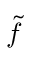<formula> <loc_0><loc_0><loc_500><loc_500>\tilde { f }</formula> 